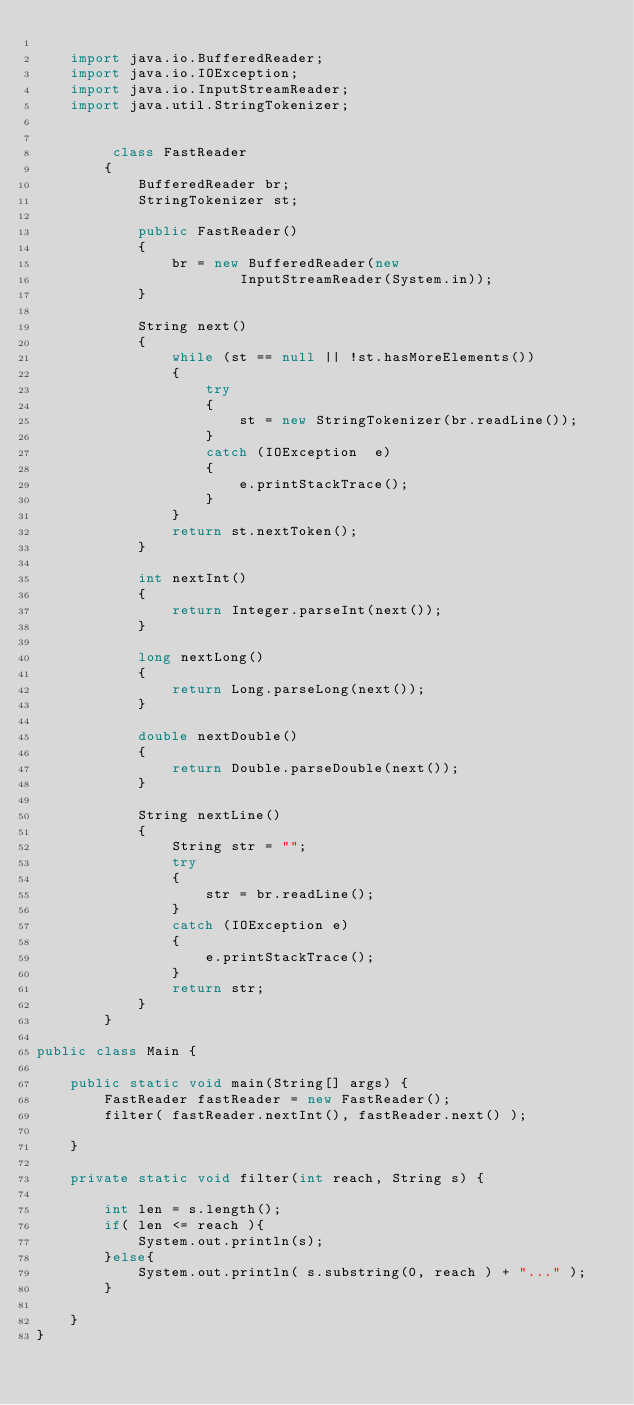<code> <loc_0><loc_0><loc_500><loc_500><_Java_>
    import java.io.BufferedReader;
    import java.io.IOException;
    import java.io.InputStreamReader;
    import java.util.StringTokenizer;


         class FastReader
        {
            BufferedReader br;
            StringTokenizer st;

            public FastReader()
            {
                br = new BufferedReader(new
                        InputStreamReader(System.in));
            }

            String next()
            {
                while (st == null || !st.hasMoreElements())
                {
                    try
                    {
                        st = new StringTokenizer(br.readLine());
                    }
                    catch (IOException  e)
                    {
                        e.printStackTrace();
                    }
                }
                return st.nextToken();
            }

            int nextInt()
            {
                return Integer.parseInt(next());
            }

            long nextLong()
            {
                return Long.parseLong(next());
            }

            double nextDouble()
            {
                return Double.parseDouble(next());
            }

            String nextLine()
            {
                String str = "";
                try
                {
                    str = br.readLine();
                }
                catch (IOException e)
                {
                    e.printStackTrace();
                }
                return str;
            }
        }

public class Main {

    public static void main(String[] args) {
        FastReader fastReader = new FastReader();
        filter( fastReader.nextInt(), fastReader.next() );

    }

    private static void filter(int reach, String s) {

        int len = s.length();
        if( len <= reach ){
            System.out.println(s);
        }else{
            System.out.println( s.substring(0, reach ) + "..." );
        }

    }
}
</code> 